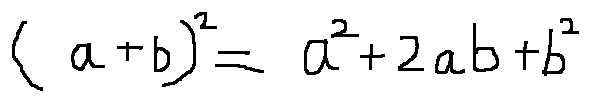<formula> <loc_0><loc_0><loc_500><loc_500>( a + b ) ^ { 2 } = a ^ { 2 } + 2 a b + b ^ { 2 }</formula> 